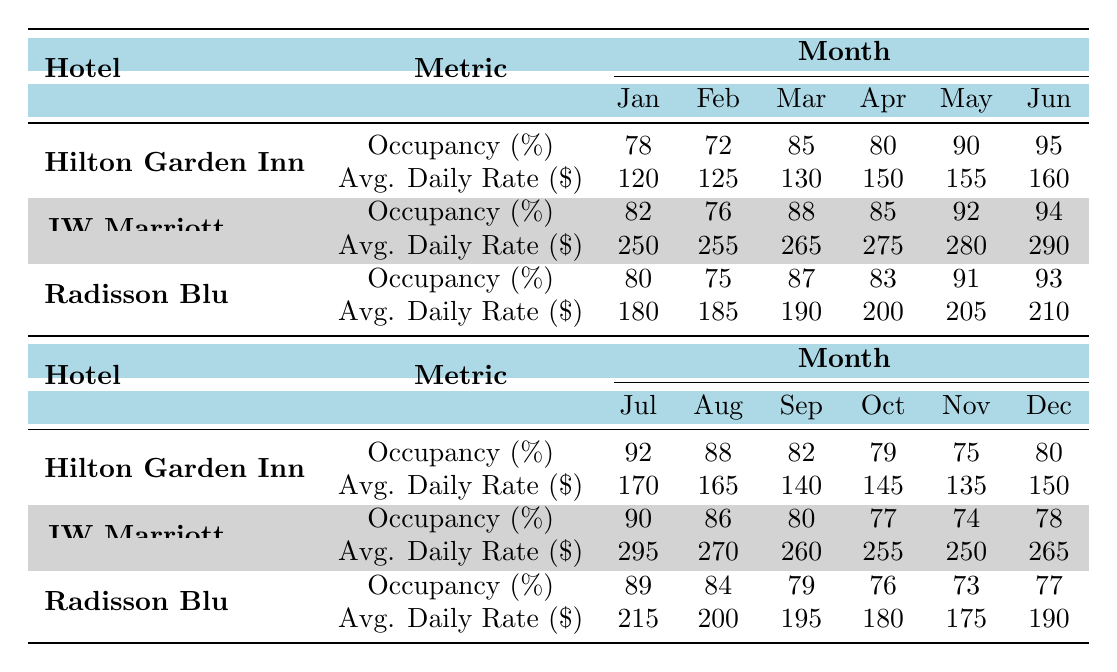What was the highest occupancy rate for Hilton Garden Inn Bucharest? Looking at the monthly occupancy rates in the table for Hilton Garden Inn, the highest value is in June, which is 95%.
Answer: 95 Which hotel had the highest average daily rate in May? In May, the JW Marriott Bucharest Grand Hotel had the highest average daily rate of 280 dollars, compared to 155 dollars for Hilton Garden Inn and 205 dollars for Radisson Blu.
Answer: 280 Did Radisson Blu Hotel's occupancy rate ever drop below 75%? Yes, if we check the occupancy rates for Radisson Blu, we see that in November it was 73%, which is below 75%.
Answer: Yes What is the average occupancy rate for JW Marriott Bucharest Grand Hotel over the entire year? To find the average, we must sum the monthly occupancy rates: (82 + 76 + 88 + 85 + 92 + 94 + 90 + 86 + 80 + 77 + 74 + 78) = 1,089. There are 12 months, so the average is 1,089 / 12 = 90.75.
Answer: 90.75 What was the occupancy rate of the hotels in August? The occupancy rates in August were as follows: Hilton Garden Inn 88%, JW Marriott 86%, and Radisson Blu 84%.
Answer: Hilton Garden Inn 88%, JW Marriott 86%, Radisson Blu 84% If we combine the average daily rate of Radisson Blu and JW Marriott in December, what is the total? The average daily rate for Radisson Blu in December is 190 dollars and for JW Marriott it's 265 dollars. We sum these amounts: 190 + 265 = 455 dollars.
Answer: 455 